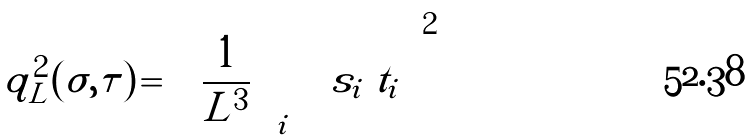<formula> <loc_0><loc_0><loc_500><loc_500>q ^ { 2 } _ { L } ( \sigma , \tau ) \, = \, \left ( \frac { 1 } { L ^ { 3 } } \sum _ { i } \ s _ { i } \ t _ { i } \right ) ^ { 2 }</formula> 